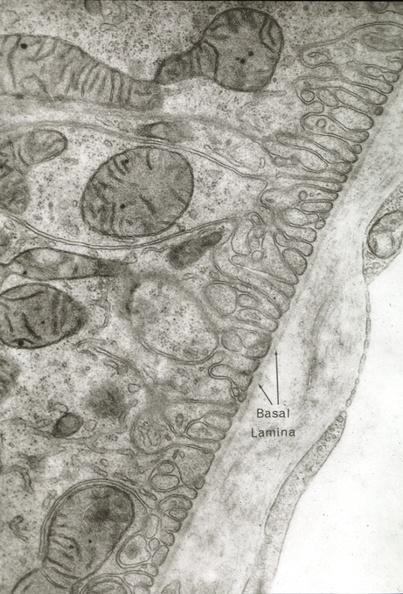does this image show proximal tubule and fenestrated capillary can be used to illustrate capillary epithelial cell relations and functions?
Answer the question using a single word or phrase. Yes 